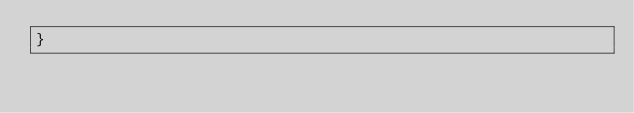<code> <loc_0><loc_0><loc_500><loc_500><_Rust_>}
</code> 